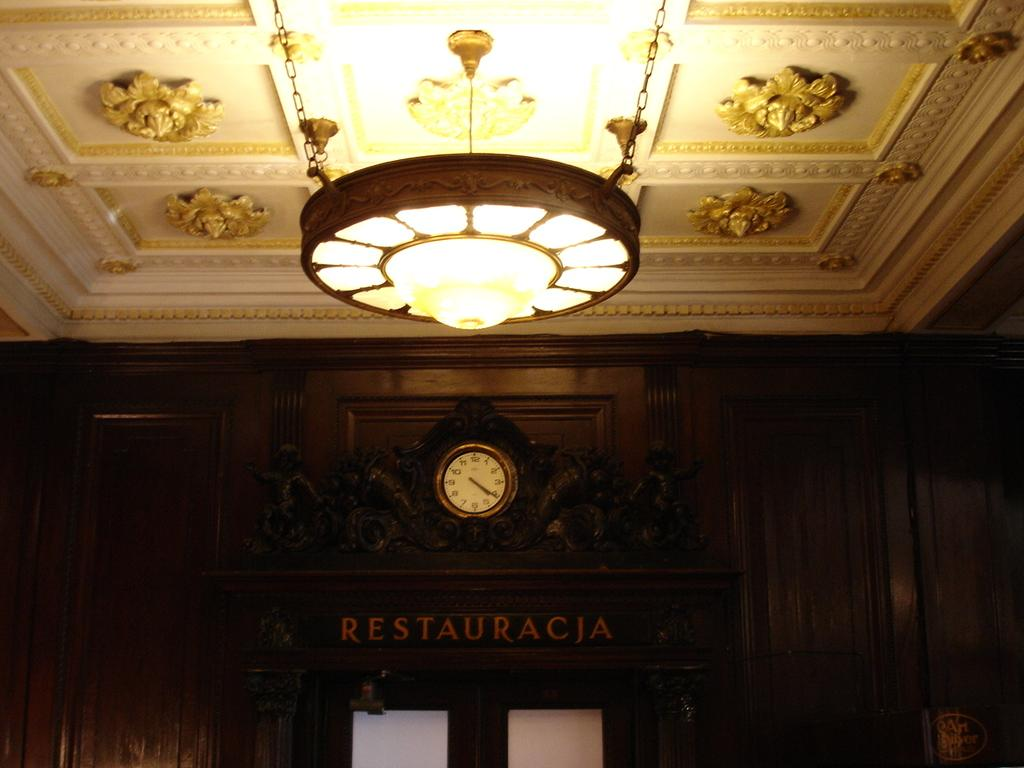Provide a one-sentence caption for the provided image. A gold framed clock hangs over a sign reading Restauracja. 